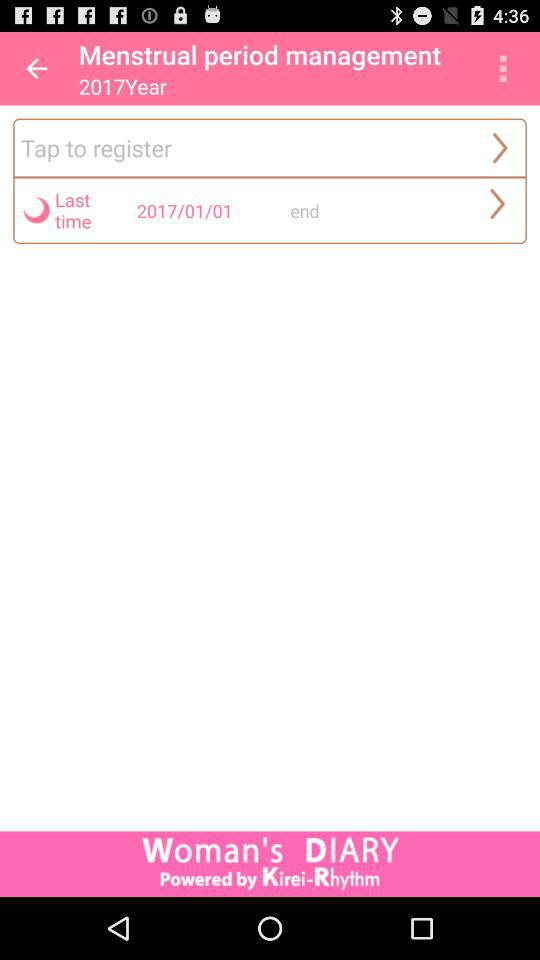What is the date? The date is January 1, 2017. 